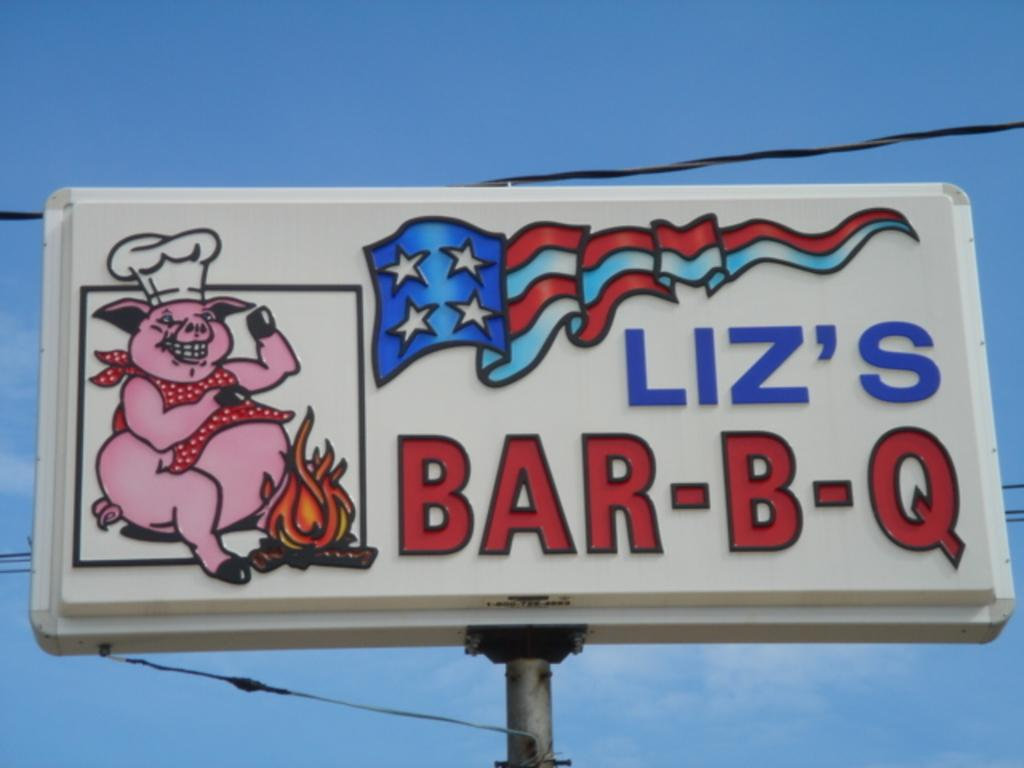<image>
Present a compact description of the photo's key features. A sign featuring a pig is for Liz's Bar-B-Q restaurant. 